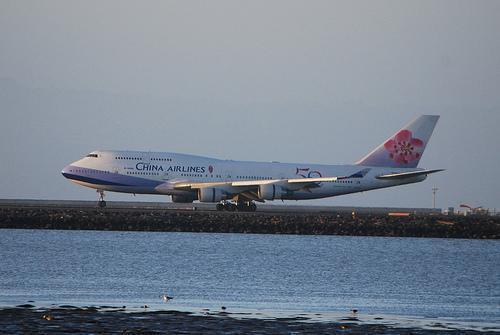How many planes are there?
Give a very brief answer. 1. 